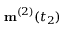Convert formula to latex. <formula><loc_0><loc_0><loc_500><loc_500>m ^ { ( 2 ) } ( t _ { 2 } )</formula> 